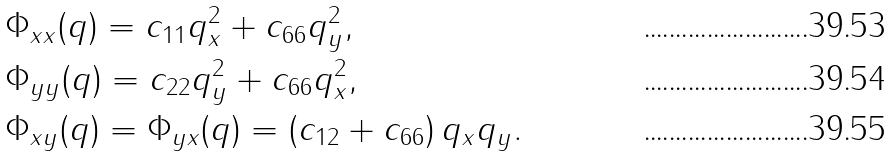<formula> <loc_0><loc_0><loc_500><loc_500>& \Phi _ { x x } ( { q } ) = c _ { 1 1 } q _ { x } ^ { 2 } + c _ { 6 6 } q _ { y } ^ { 2 } , \\ & \Phi _ { y y } ( { q } ) = c _ { 2 2 } q _ { y } ^ { 2 } + c _ { 6 6 } q _ { x } ^ { 2 } , \\ & \Phi _ { x y } ( { q } ) = \Phi _ { y x } ( { q } ) = \left ( c _ { 1 2 } + c _ { 6 6 } \right ) q _ { x } q _ { y } .</formula> 